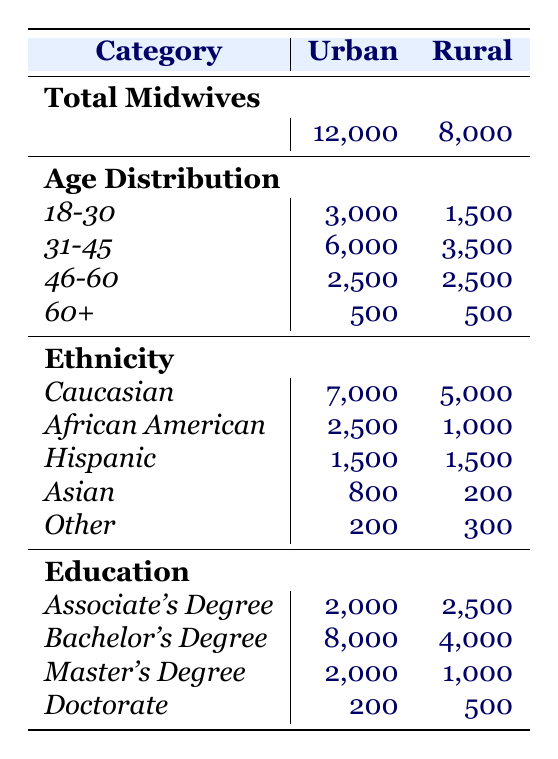What is the total number of midwives practicing in urban areas? The table indicates that the total number of midwives in urban areas is listed under the "Total Midwives" row for urban, which shows 12,000.
Answer: 12,000 How many midwives in rural areas have a Bachelor's Degree? In the "Education" section of the rural area, the number of midwives with a Bachelor's Degree is specified as 4,000.
Answer: 4,000 What is the difference between the total number of midwives in urban and rural areas? According to the table, urban midwives total 12,000 and rural midwives total 8,000. The difference is calculated as 12,000 - 8,000 = 4,000.
Answer: 4,000 Which age group of midwives has the highest representation in urban areas? The age distribution for urban areas shows that the 31-45 age group has 6,000 midwives, which is the highest number compared to other age groups.
Answer: 31-45 What is the total number of midwives aged 46 and over in rural areas? The table shows that in rural areas, the 46-60 age group has 2,500 midwives and the 60+ age group has 500 midwives, so the total is 2,500 + 500 = 3,000.
Answer: 3,000 True or False: The number of Hispanic midwives is equal in both urban and rural areas. The data shows that there are 1,500 Hispanic midwives in urban areas and 1,500 in rural areas, indicating they are equal.
Answer: True What percentage of urban midwives hold a Master's Degree? The table lists 2,000 midwives with a Master's Degree in urban areas out of a total of 12,000 midwives. The percentage is calculated as (2,000 / 12,000) * 100 = 16.67%.
Answer: 16.67% How many more Caucasian midwives are there in urban areas compared to African American midwives in the same area? In urban areas, there are 7,000 Caucasian midwives and 2,500 African American midwives. The difference is 7,000 - 2,500 = 4,500.
Answer: 4,500 What is the median age group of midwives practicing in rural areas? The age groups for rural areas are 18-30, 31-45, 46-60, and 60+. With the counts of 1,500, 3,500, 2,500, and 500 respectively, the median is the average of the second and third groups (31-45 and 46-60), computed as (3,500 + 2,500) / 2. Hence, the median age group is 31-45.
Answer: 31-45 What proportion of urban midwives have an Associate's Degree compared to those with a Doctorate? In urban areas, 2,000 have an Associate's Degree and 200 have a Doctorate. The proportion is 2,000 / 200 = 10, indicating that for every Doctoral midwife, there are 10 with an Associate's Degree.
Answer: 10 